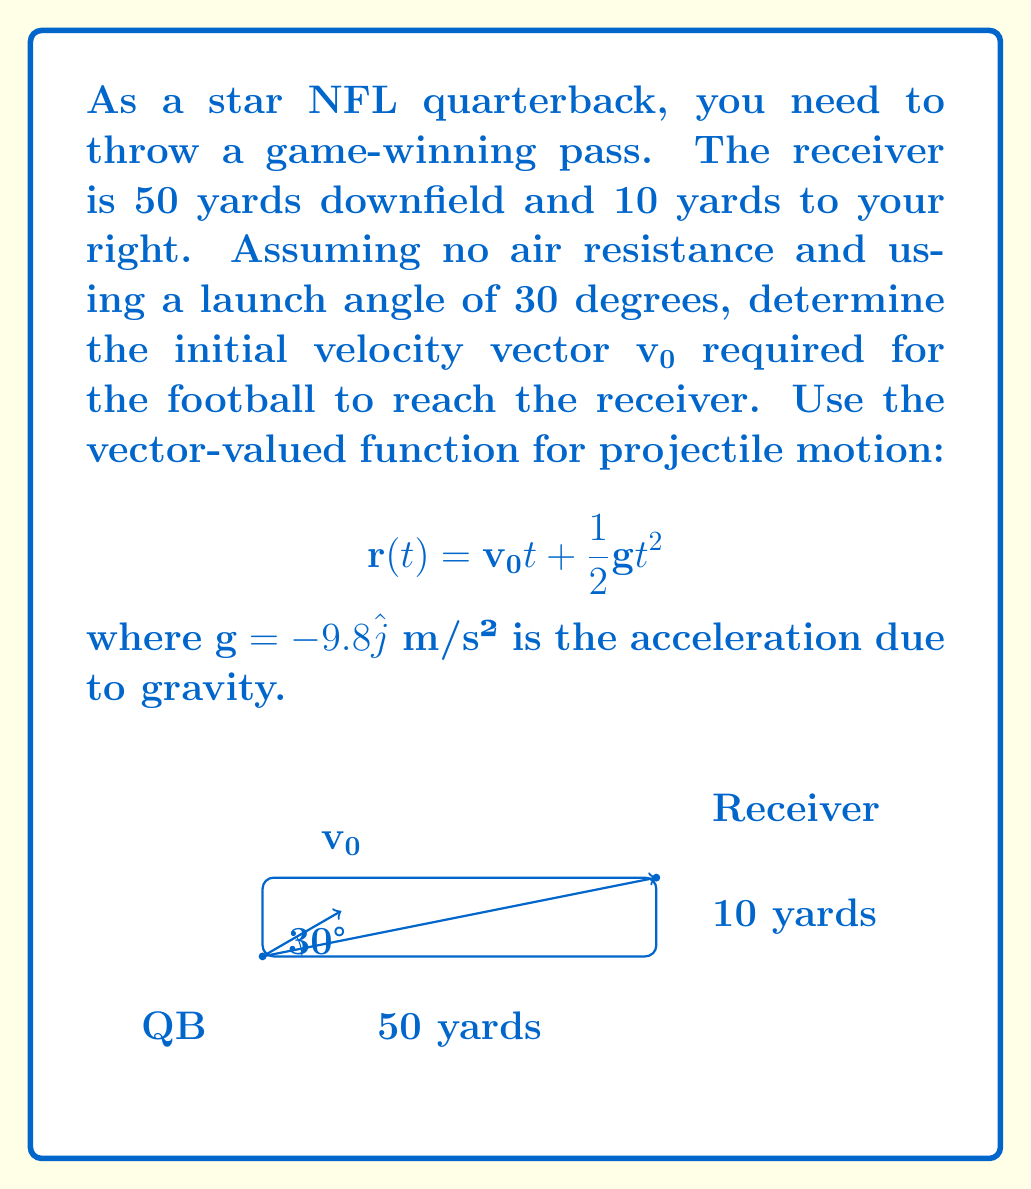Can you solve this math problem? Let's solve this step-by-step:

1) First, convert yards to meters: 50 yards ≈ 45.72 m, 10 yards ≈ 9.14 m

2) The position vector to the receiver is $\mathbf{r} = 45.72\hat{i} + 9.14\hat{j}$

3) We need to find $\mathbf{v_0}$. Let $\mathbf{v_0} = v_0\cos(30°)\hat{i} + v_0\sin(30°)\hat{j}$

4) The time of flight $t$ can be found using the vertical component:
   $9.14 = v_0\sin(30°)t - \frac{1}{2}(9.8)t^2$

5) Solving this quadratic equation:
   $4.9t^2 - 0.5v_0t - 9.14 = 0$

6) Using the horizontal component:
   $45.72 = v_0\cos(30°)t$

7) Substitute this into the quadratic equation:
   $4.9(\frac{45.72}{v_0\cos(30°)})^2 - 0.5v_0(\frac{45.72}{v_0\cos(30°)}) - 9.14 = 0$

8) Simplify and solve for $v_0$:
   $v_0 ≈ 22.53$ m/s

9) Now we can find the components of $\mathbf{v_0}$:
   $v_0\cos(30°) ≈ 19.51$ m/s
   $v_0\sin(30°) ≈ 11.27$ m/s

Therefore, $\mathbf{v_0} ≈ 19.51\hat{i} + 11.27\hat{j}$ m/s.
Answer: $\mathbf{v_0} ≈ 19.51\hat{i} + 11.27\hat{j}$ m/s 